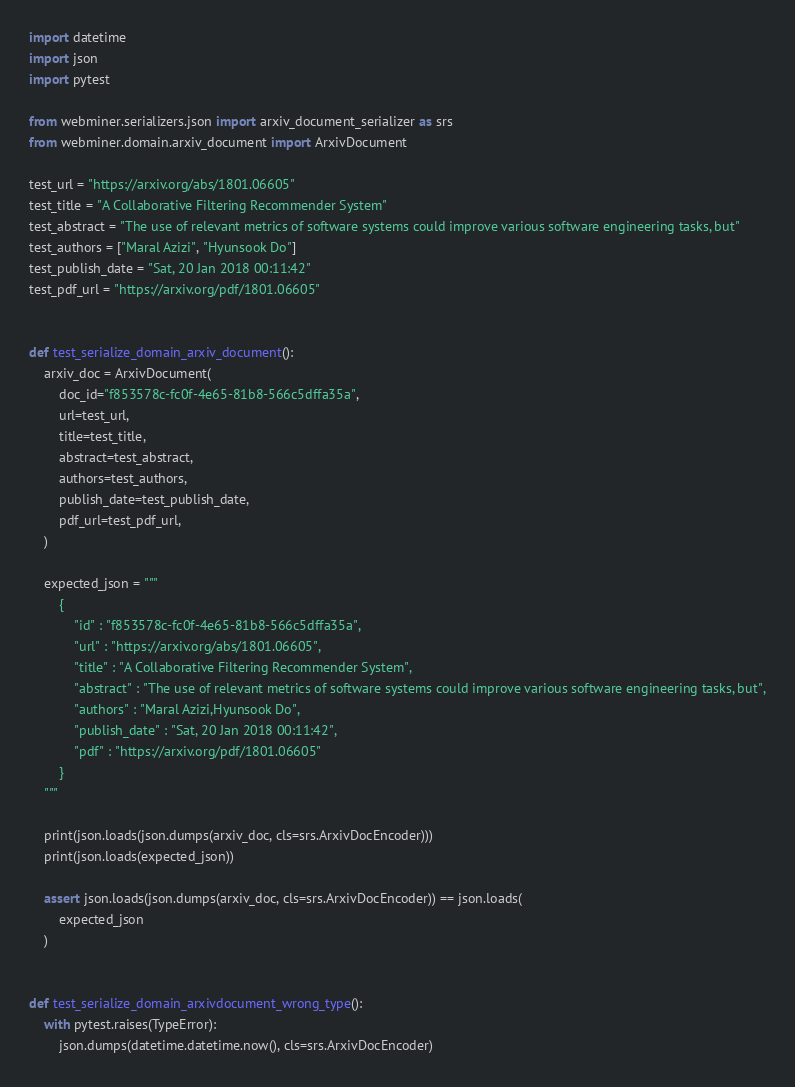<code> <loc_0><loc_0><loc_500><loc_500><_Python_>import datetime
import json
import pytest

from webminer.serializers.json import arxiv_document_serializer as srs
from webminer.domain.arxiv_document import ArxivDocument

test_url = "https://arxiv.org/abs/1801.06605"
test_title = "A Collaborative Filtering Recommender System"
test_abstract = "The use of relevant metrics of software systems could improve various software engineering tasks, but"
test_authors = ["Maral Azizi", "Hyunsook Do"]
test_publish_date = "Sat, 20 Jan 2018 00:11:42"
test_pdf_url = "https://arxiv.org/pdf/1801.06605"


def test_serialize_domain_arxiv_document():
    arxiv_doc = ArxivDocument(
        doc_id="f853578c-fc0f-4e65-81b8-566c5dffa35a",
        url=test_url,
        title=test_title,
        abstract=test_abstract,
        authors=test_authors,
        publish_date=test_publish_date,
        pdf_url=test_pdf_url,
    )

    expected_json = """
        {
            "id" : "f853578c-fc0f-4e65-81b8-566c5dffa35a",
            "url" : "https://arxiv.org/abs/1801.06605",
            "title" : "A Collaborative Filtering Recommender System",
            "abstract" : "The use of relevant metrics of software systems could improve various software engineering tasks, but",
            "authors" : "Maral Azizi,Hyunsook Do",
            "publish_date" : "Sat, 20 Jan 2018 00:11:42",
            "pdf" : "https://arxiv.org/pdf/1801.06605"
        }
    """

    print(json.loads(json.dumps(arxiv_doc, cls=srs.ArxivDocEncoder)))
    print(json.loads(expected_json))

    assert json.loads(json.dumps(arxiv_doc, cls=srs.ArxivDocEncoder)) == json.loads(
        expected_json
    )


def test_serialize_domain_arxivdocument_wrong_type():
    with pytest.raises(TypeError):
        json.dumps(datetime.datetime.now(), cls=srs.ArxivDocEncoder)
</code> 